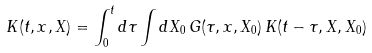Convert formula to latex. <formula><loc_0><loc_0><loc_500><loc_500>K ( t , x , X ) = \int _ { 0 } ^ { t } d \tau \int d X _ { 0 } \, G ( \tau , x , X _ { 0 } ) \, K ( t - \tau , X , X _ { 0 } )</formula> 